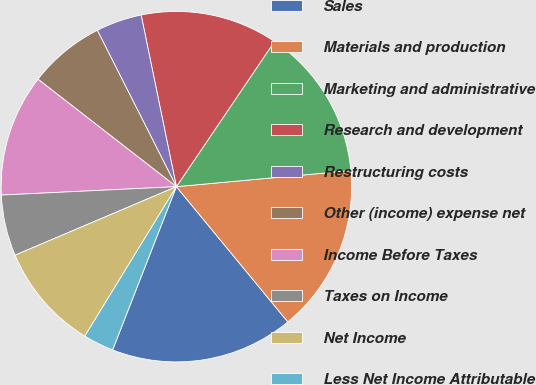<chart> <loc_0><loc_0><loc_500><loc_500><pie_chart><fcel>Sales<fcel>Materials and production<fcel>Marketing and administrative<fcel>Research and development<fcel>Restructuring costs<fcel>Other (income) expense net<fcel>Income Before Taxes<fcel>Taxes on Income<fcel>Net Income<fcel>Less Net Income Attributable<nl><fcel>16.9%<fcel>15.49%<fcel>14.08%<fcel>12.68%<fcel>4.23%<fcel>7.04%<fcel>11.27%<fcel>5.63%<fcel>9.86%<fcel>2.82%<nl></chart> 